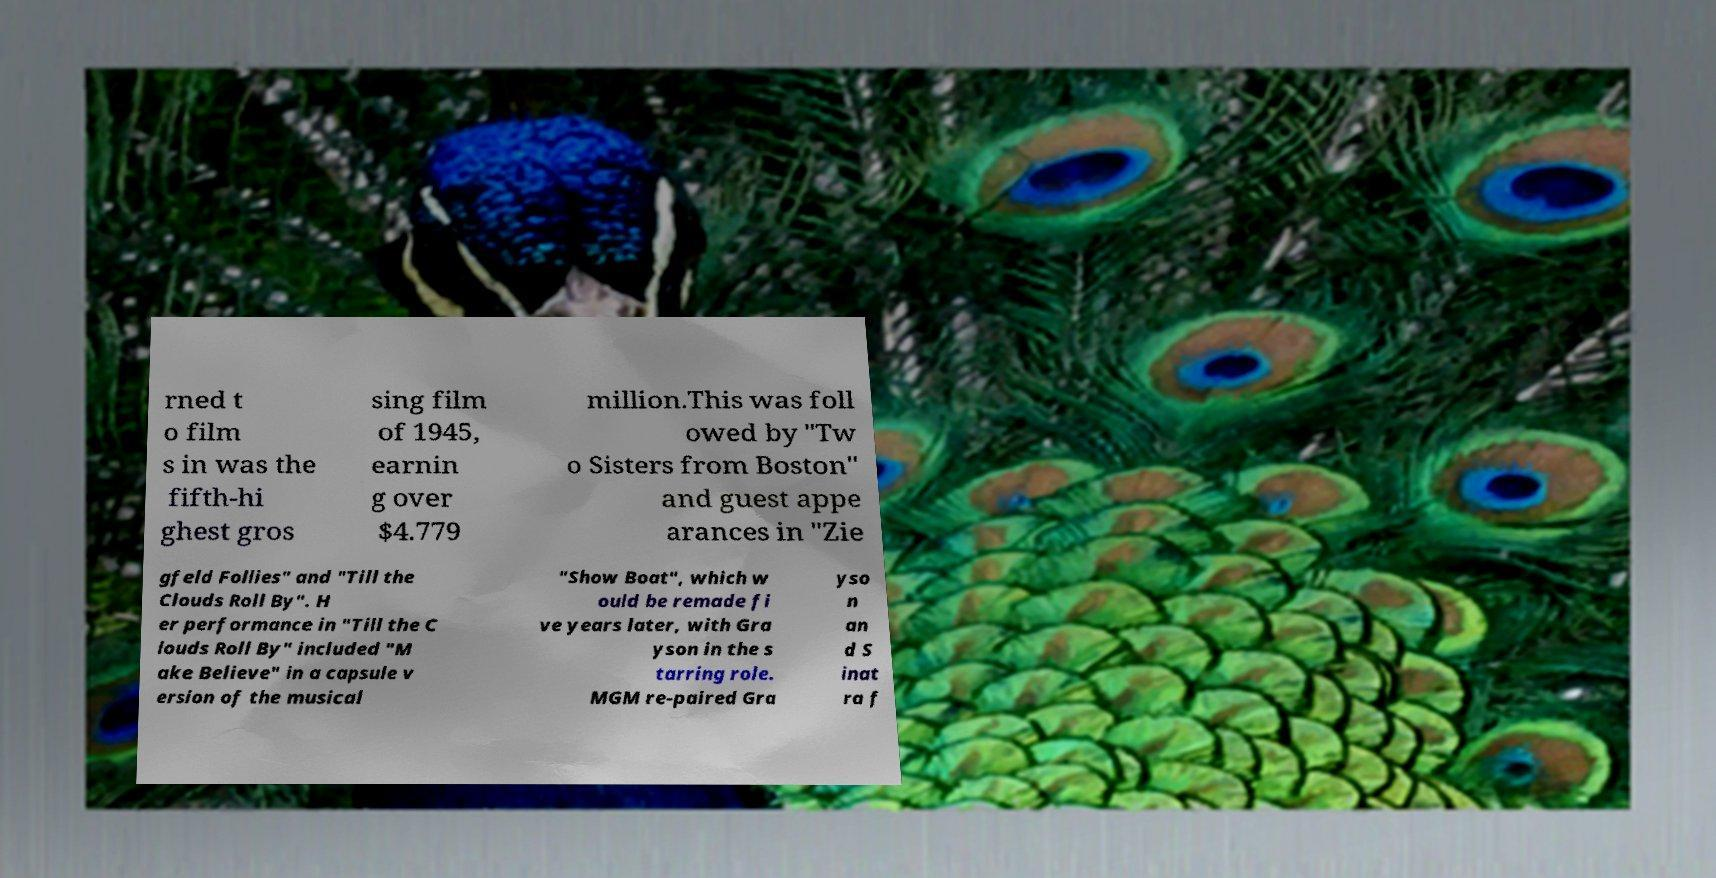There's text embedded in this image that I need extracted. Can you transcribe it verbatim? rned t o film s in was the fifth-hi ghest gros sing film of 1945, earnin g over $4.779 million.This was foll owed by "Tw o Sisters from Boston" and guest appe arances in "Zie gfeld Follies" and "Till the Clouds Roll By". H er performance in "Till the C louds Roll By" included "M ake Believe" in a capsule v ersion of the musical "Show Boat", which w ould be remade fi ve years later, with Gra yson in the s tarring role. MGM re-paired Gra yso n an d S inat ra f 